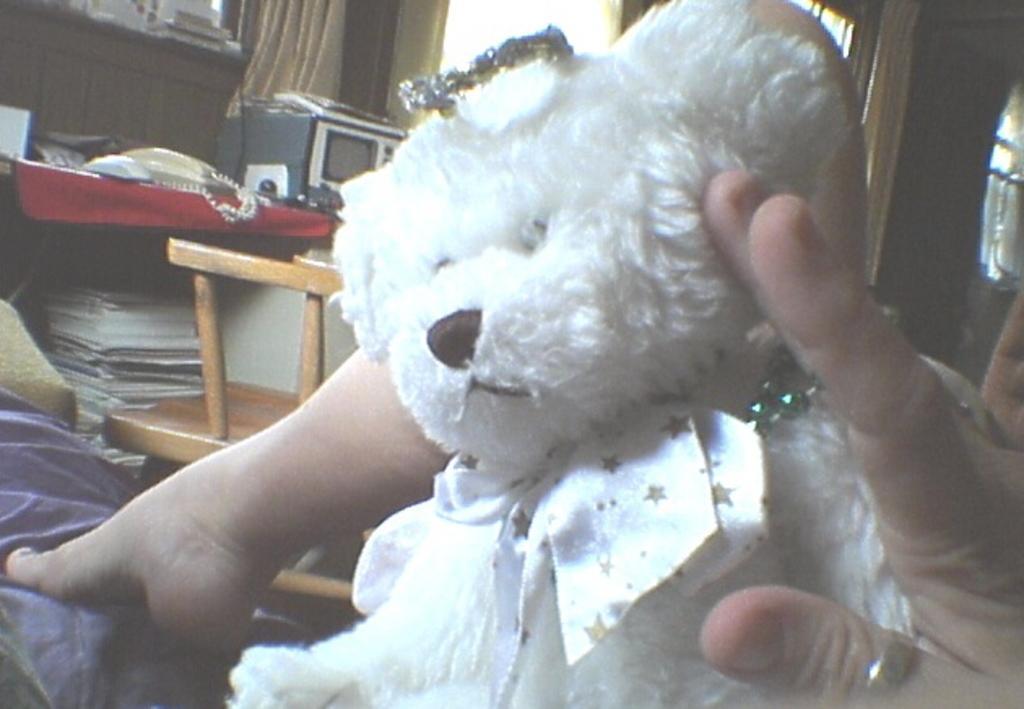Can you describe this image briefly? In front of the picture, we see a teddy bear in white color. Behind that, we see the hand and the leg of the person. On the left side, we see a table on which an oven, telephone and some other objects are placed. We see the books under the table. Beside that, we see a chair. In the left bottom, we see a bed and a blanket in purple color. In the background, we see a white wall, windows and a curtain. 